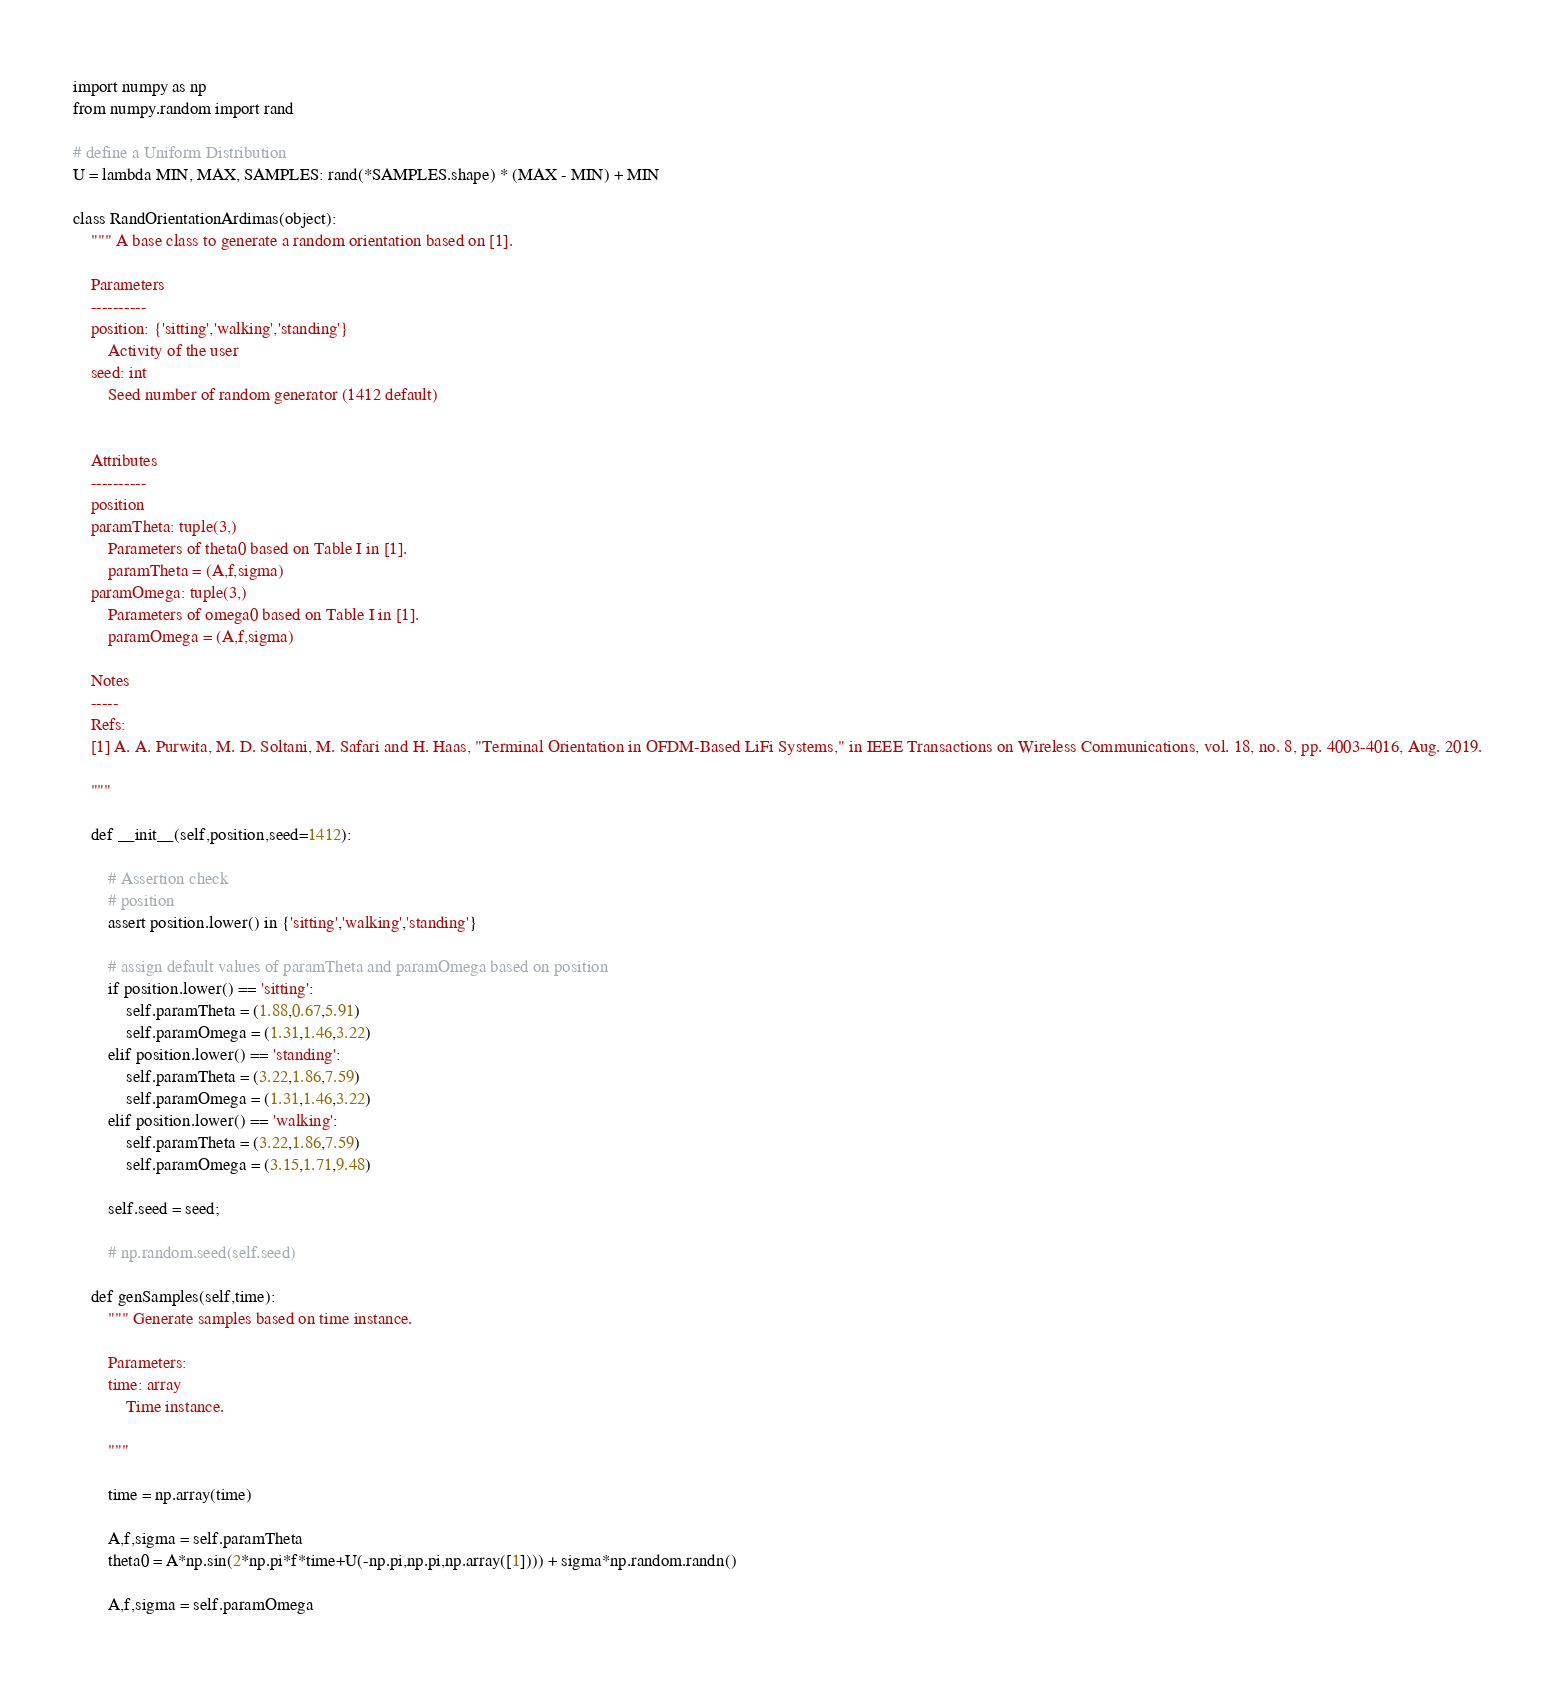Convert code to text. <code><loc_0><loc_0><loc_500><loc_500><_Python_>import numpy as np
from numpy.random import rand

# define a Uniform Distribution
U = lambda MIN, MAX, SAMPLES: rand(*SAMPLES.shape) * (MAX - MIN) + MIN

class RandOrientationArdimas(object):
    """ A base class to generate a random orientation based on [1].

    Parameters
    ----------
    position: {'sitting','walking','standing'} 
        Activity of the user
    seed: int
        Seed number of random generator (1412 default)


    Attributes
    ----------
    position
    paramTheta: tuple(3,)
        Parameters of theta0 based on Table I in [1].
        paramTheta = (A,f,sigma)
    paramOmega: tuple(3,)
        Parameters of omega0 based on Table I in [1].
        paramOmega = (A,f,sigma)

    Notes
    -----
    Refs: 
    [1] A. A. Purwita, M. D. Soltani, M. Safari and H. Haas, "Terminal Orientation in OFDM-Based LiFi Systems," in IEEE Transactions on Wireless Communications, vol. 18, no. 8, pp. 4003-4016, Aug. 2019.

    """

    def __init__(self,position,seed=1412):

        # Assertion check
        # position
        assert position.lower() in {'sitting','walking','standing'}

        # assign default values of paramTheta and paramOmega based on position
        if position.lower() == 'sitting':
            self.paramTheta = (1.88,0.67,5.91)
            self.paramOmega = (1.31,1.46,3.22)
        elif position.lower() == 'standing':
            self.paramTheta = (3.22,1.86,7.59)
            self.paramOmega = (1.31,1.46,3.22)
        elif position.lower() == 'walking':
            self.paramTheta = (3.22,1.86,7.59)
            self.paramOmega = (3.15,1.71,9.48)

        self.seed = seed;

        # np.random.seed(self.seed)

    def genSamples(self,time):
        """ Generate samples based on time instance.
        
        Parameters:
        time: array
            Time instance.

        """

        time = np.array(time)

        A,f,sigma = self.paramTheta
        theta0 = A*np.sin(2*np.pi*f*time+U(-np.pi,np.pi,np.array([1]))) + sigma*np.random.randn()

        A,f,sigma = self.paramOmega</code> 